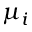<formula> <loc_0><loc_0><loc_500><loc_500>\mu _ { i }</formula> 